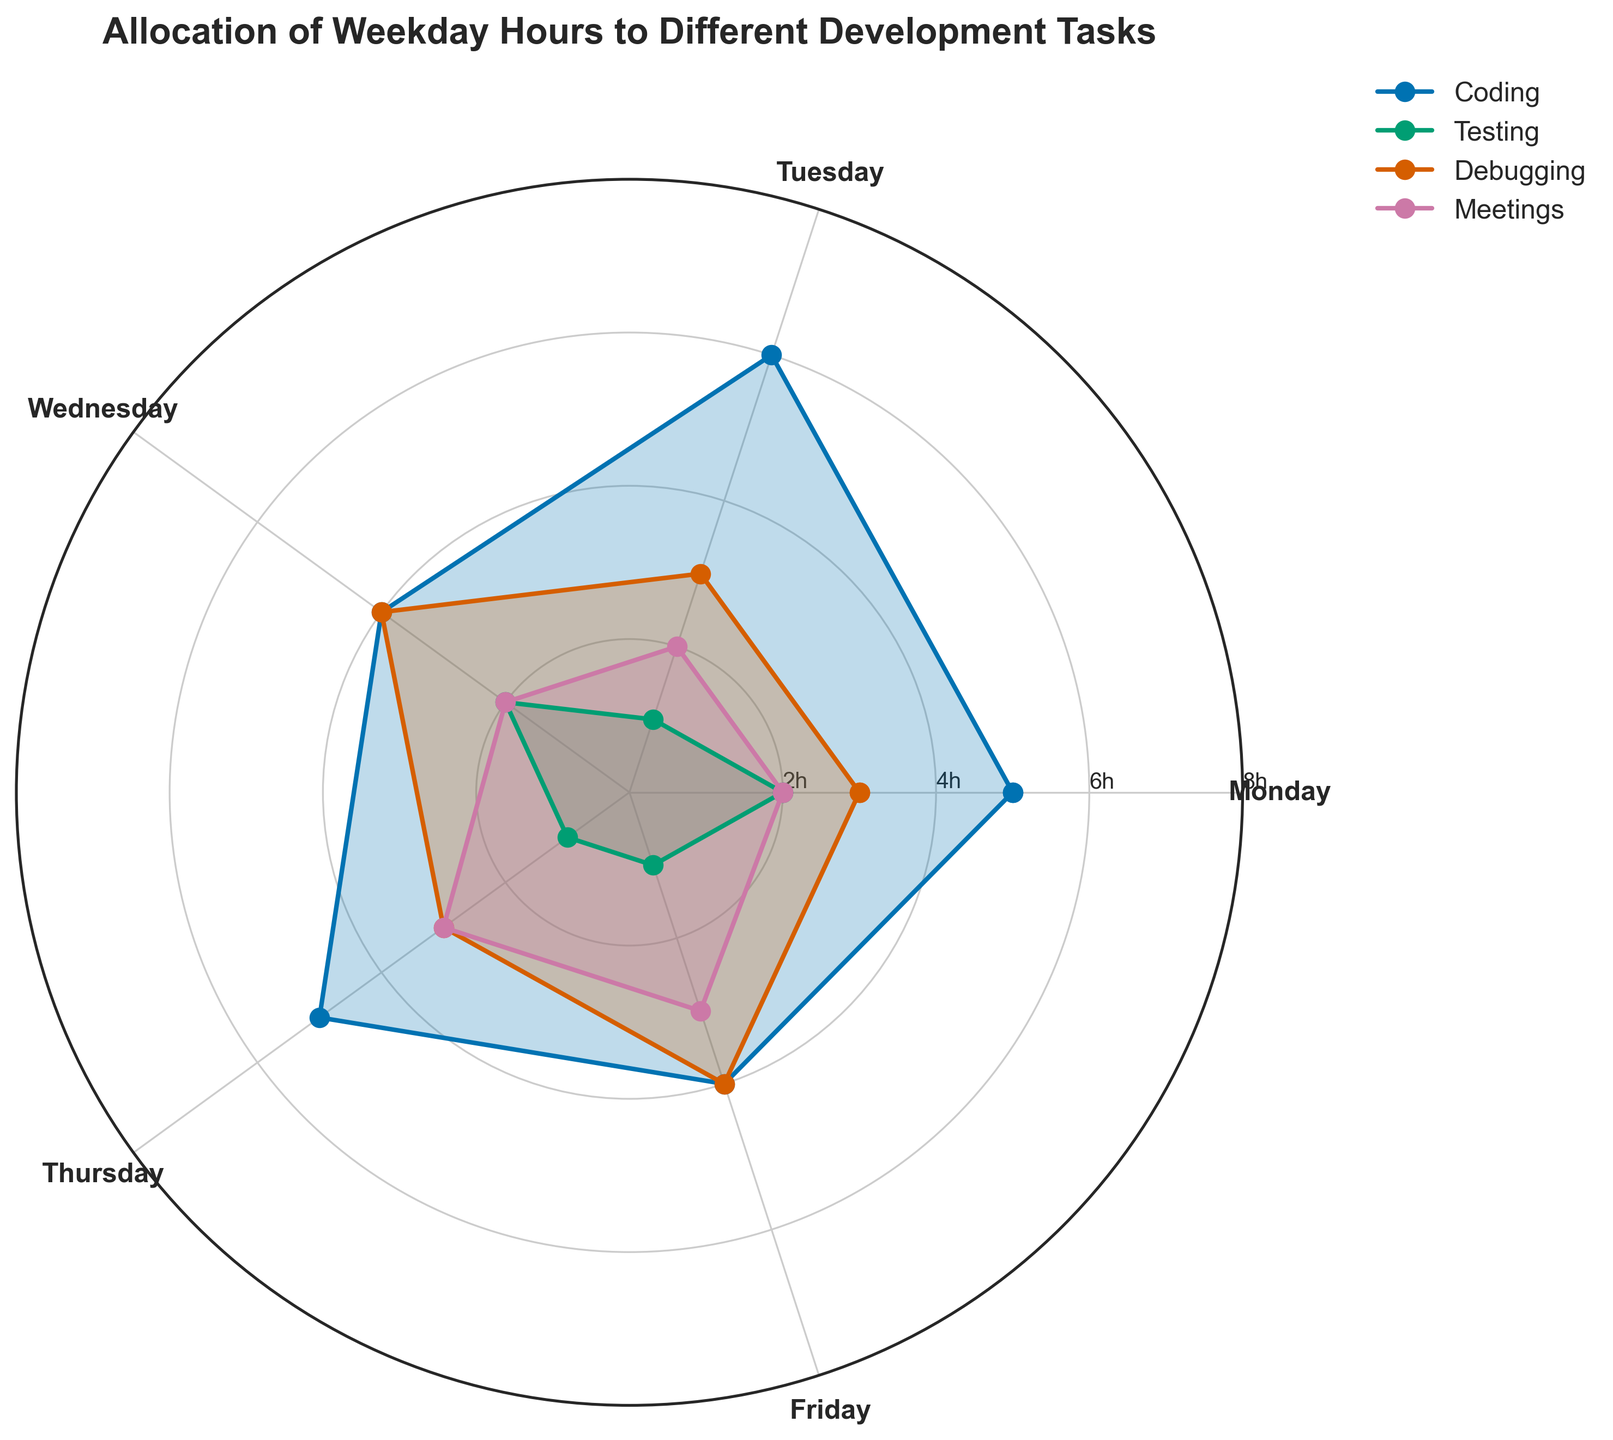What's the title of the chart? The title of a chart is usually displayed at the top of the figure, providing a brief overview or description of the visualized data. The title of this chart is "Allocation of Weekday Hours to Different Development Tasks."
Answer: Allocation of Weekday Hours to Different Development Tasks How many distinct tasks are displayed in the chart? To identify the number of distinct tasks, look at the legend on the chart, which lists all the task categories represented by different lines and colored areas. There are four distinct tasks: Coding, Testing, Debugging, and Meetings.
Answer: 4 On which day is the maximum number of coding hours allocated? Observe the plot and identify the day where the coding line (represented by its specific color) reaches its highest radial value on the polar chart. Tuesday shows the maximum number of coding hours, which is at 6 hours.
Answer: Tuesday Which task has the most uniform distribution of hours across all weekdays? Uniform distribution means the values are relatively similar for all days. By examining the filled areas and lines for each task, we notice that 'Meetings' has the most consistent distribution across all weekdays, with hours ranging closely around 2 to 3 hours.
Answer: Meetings What are the total debugging hours for Tuesdays and Thursdays? Sum the hours allocated to debugging for Tuesday and Thursday by checking these specific segments on the polar chart for the debugging line. On Tuesday, there are 3 hours and on Thursday, there are also 3 hours. Therefore, the total is 3 + 3 = 6 hours.
Answer: 6 Which day has the lowest combined total hours for all tasks? Add up the hours for each task on each day and compare to find the smallest total. Summing the values for each day: Monday (12 hours), Tuesday (12 hours), Wednesday (12 hours), Thursday (12 hours), and Friday (12 hours). Here, each day appears to have the same combined total hours of 12. Therefore, there’s no day with a specifically lower combined total.
Answer: No specific day (all are equal) Is there any day where more hours are allocated to Testing than to Coding? Compare the values for Testing and Coding for each day. For Monday, Testing = 2, Coding = 5; for Tuesday, Testing = 1, Coding = 6; Wednesday, Testing = 2, Coding = 4; Thursday, Testing = 1, Coding = 5; Friday, Testing = 1, Coding = 4. In all cases, the hours allocated to Coding are higher than those allocated to Testing.
Answer: No Which task shows the greatest variability in hours allocation throughout the week? Variability refers to the range of values being the largest. Coding hours range from 4 to 6, Testing hours range from 1 to 2, Debugging hours range from 3 to 4, and Meetings hours range from 2 to 3. Coding shows the greatest variability because the range (difference between max and min) is the largest, which is 2 hours (6 - 4).
Answer: Coding 